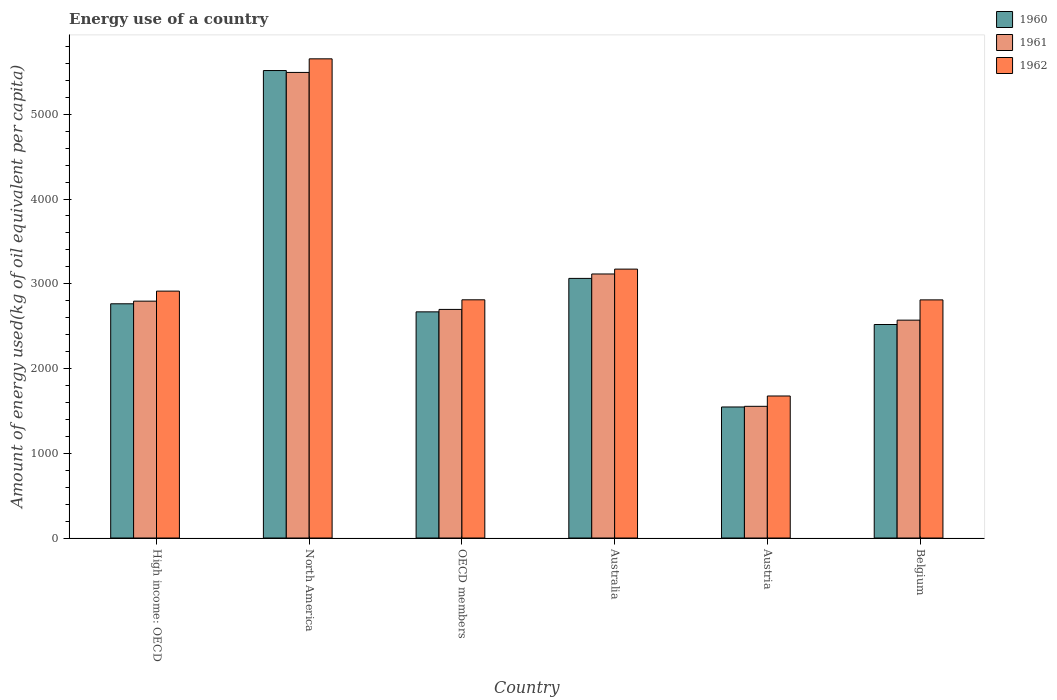How many groups of bars are there?
Make the answer very short. 6. Are the number of bars on each tick of the X-axis equal?
Keep it short and to the point. Yes. How many bars are there on the 1st tick from the right?
Your answer should be compact. 3. In how many cases, is the number of bars for a given country not equal to the number of legend labels?
Keep it short and to the point. 0. What is the amount of energy used in in 1962 in OECD members?
Provide a short and direct response. 2810.85. Across all countries, what is the maximum amount of energy used in in 1960?
Give a very brief answer. 5516.36. Across all countries, what is the minimum amount of energy used in in 1960?
Make the answer very short. 1546.26. What is the total amount of energy used in in 1961 in the graph?
Ensure brevity in your answer.  1.82e+04. What is the difference between the amount of energy used in in 1960 in Austria and that in High income: OECD?
Provide a short and direct response. -1217.7. What is the difference between the amount of energy used in in 1960 in North America and the amount of energy used in in 1961 in Austria?
Make the answer very short. 3962.32. What is the average amount of energy used in in 1960 per country?
Provide a succinct answer. 3013.05. What is the difference between the amount of energy used in of/in 1961 and amount of energy used in of/in 1962 in Belgium?
Keep it short and to the point. -239.25. What is the ratio of the amount of energy used in in 1960 in Australia to that in Austria?
Your answer should be very brief. 1.98. Is the amount of energy used in in 1962 in High income: OECD less than that in OECD members?
Ensure brevity in your answer.  No. What is the difference between the highest and the second highest amount of energy used in in 1962?
Give a very brief answer. -259.55. What is the difference between the highest and the lowest amount of energy used in in 1960?
Your answer should be compact. 3970.09. Is the sum of the amount of energy used in in 1962 in High income: OECD and North America greater than the maximum amount of energy used in in 1960 across all countries?
Offer a very short reply. Yes. What does the 1st bar from the left in North America represents?
Keep it short and to the point. 1960. How many bars are there?
Ensure brevity in your answer.  18. Are all the bars in the graph horizontal?
Provide a succinct answer. No. How many countries are there in the graph?
Provide a short and direct response. 6. What is the difference between two consecutive major ticks on the Y-axis?
Your answer should be compact. 1000. Does the graph contain grids?
Offer a terse response. No. Where does the legend appear in the graph?
Offer a terse response. Top right. How many legend labels are there?
Your response must be concise. 3. What is the title of the graph?
Provide a short and direct response. Energy use of a country. Does "1968" appear as one of the legend labels in the graph?
Your response must be concise. No. What is the label or title of the Y-axis?
Make the answer very short. Amount of energy used(kg of oil equivalent per capita). What is the Amount of energy used(kg of oil equivalent per capita) of 1960 in High income: OECD?
Keep it short and to the point. 2763.96. What is the Amount of energy used(kg of oil equivalent per capita) in 1961 in High income: OECD?
Give a very brief answer. 2795.14. What is the Amount of energy used(kg of oil equivalent per capita) of 1962 in High income: OECD?
Give a very brief answer. 2913.43. What is the Amount of energy used(kg of oil equivalent per capita) in 1960 in North America?
Keep it short and to the point. 5516.36. What is the Amount of energy used(kg of oil equivalent per capita) of 1961 in North America?
Give a very brief answer. 5494.09. What is the Amount of energy used(kg of oil equivalent per capita) of 1962 in North America?
Your response must be concise. 5654.54. What is the Amount of energy used(kg of oil equivalent per capita) of 1960 in OECD members?
Your response must be concise. 2668.69. What is the Amount of energy used(kg of oil equivalent per capita) of 1961 in OECD members?
Provide a succinct answer. 2697.51. What is the Amount of energy used(kg of oil equivalent per capita) in 1962 in OECD members?
Ensure brevity in your answer.  2810.85. What is the Amount of energy used(kg of oil equivalent per capita) of 1960 in Australia?
Your response must be concise. 3063.55. What is the Amount of energy used(kg of oil equivalent per capita) in 1961 in Australia?
Provide a short and direct response. 3115.79. What is the Amount of energy used(kg of oil equivalent per capita) in 1962 in Australia?
Make the answer very short. 3172.97. What is the Amount of energy used(kg of oil equivalent per capita) in 1960 in Austria?
Your answer should be compact. 1546.26. What is the Amount of energy used(kg of oil equivalent per capita) of 1961 in Austria?
Provide a short and direct response. 1554.03. What is the Amount of energy used(kg of oil equivalent per capita) in 1962 in Austria?
Offer a very short reply. 1675.87. What is the Amount of energy used(kg of oil equivalent per capita) in 1960 in Belgium?
Provide a short and direct response. 2519.5. What is the Amount of energy used(kg of oil equivalent per capita) in 1961 in Belgium?
Keep it short and to the point. 2570.82. What is the Amount of energy used(kg of oil equivalent per capita) of 1962 in Belgium?
Provide a succinct answer. 2810.06. Across all countries, what is the maximum Amount of energy used(kg of oil equivalent per capita) in 1960?
Provide a short and direct response. 5516.36. Across all countries, what is the maximum Amount of energy used(kg of oil equivalent per capita) in 1961?
Ensure brevity in your answer.  5494.09. Across all countries, what is the maximum Amount of energy used(kg of oil equivalent per capita) in 1962?
Provide a succinct answer. 5654.54. Across all countries, what is the minimum Amount of energy used(kg of oil equivalent per capita) of 1960?
Offer a terse response. 1546.26. Across all countries, what is the minimum Amount of energy used(kg of oil equivalent per capita) in 1961?
Make the answer very short. 1554.03. Across all countries, what is the minimum Amount of energy used(kg of oil equivalent per capita) of 1962?
Offer a terse response. 1675.87. What is the total Amount of energy used(kg of oil equivalent per capita) in 1960 in the graph?
Your response must be concise. 1.81e+04. What is the total Amount of energy used(kg of oil equivalent per capita) in 1961 in the graph?
Provide a short and direct response. 1.82e+04. What is the total Amount of energy used(kg of oil equivalent per capita) in 1962 in the graph?
Make the answer very short. 1.90e+04. What is the difference between the Amount of energy used(kg of oil equivalent per capita) in 1960 in High income: OECD and that in North America?
Provide a succinct answer. -2752.4. What is the difference between the Amount of energy used(kg of oil equivalent per capita) of 1961 in High income: OECD and that in North America?
Your answer should be very brief. -2698.95. What is the difference between the Amount of energy used(kg of oil equivalent per capita) in 1962 in High income: OECD and that in North America?
Offer a very short reply. -2741.12. What is the difference between the Amount of energy used(kg of oil equivalent per capita) of 1960 in High income: OECD and that in OECD members?
Make the answer very short. 95.27. What is the difference between the Amount of energy used(kg of oil equivalent per capita) in 1961 in High income: OECD and that in OECD members?
Your response must be concise. 97.63. What is the difference between the Amount of energy used(kg of oil equivalent per capita) in 1962 in High income: OECD and that in OECD members?
Your answer should be very brief. 102.57. What is the difference between the Amount of energy used(kg of oil equivalent per capita) in 1960 in High income: OECD and that in Australia?
Your answer should be very brief. -299.59. What is the difference between the Amount of energy used(kg of oil equivalent per capita) of 1961 in High income: OECD and that in Australia?
Provide a short and direct response. -320.65. What is the difference between the Amount of energy used(kg of oil equivalent per capita) in 1962 in High income: OECD and that in Australia?
Keep it short and to the point. -259.55. What is the difference between the Amount of energy used(kg of oil equivalent per capita) in 1960 in High income: OECD and that in Austria?
Your answer should be compact. 1217.7. What is the difference between the Amount of energy used(kg of oil equivalent per capita) of 1961 in High income: OECD and that in Austria?
Your answer should be very brief. 1241.11. What is the difference between the Amount of energy used(kg of oil equivalent per capita) of 1962 in High income: OECD and that in Austria?
Make the answer very short. 1237.55. What is the difference between the Amount of energy used(kg of oil equivalent per capita) in 1960 in High income: OECD and that in Belgium?
Give a very brief answer. 244.46. What is the difference between the Amount of energy used(kg of oil equivalent per capita) in 1961 in High income: OECD and that in Belgium?
Provide a short and direct response. 224.32. What is the difference between the Amount of energy used(kg of oil equivalent per capita) of 1962 in High income: OECD and that in Belgium?
Keep it short and to the point. 103.36. What is the difference between the Amount of energy used(kg of oil equivalent per capita) in 1960 in North America and that in OECD members?
Your response must be concise. 2847.66. What is the difference between the Amount of energy used(kg of oil equivalent per capita) of 1961 in North America and that in OECD members?
Your answer should be compact. 2796.57. What is the difference between the Amount of energy used(kg of oil equivalent per capita) of 1962 in North America and that in OECD members?
Keep it short and to the point. 2843.69. What is the difference between the Amount of energy used(kg of oil equivalent per capita) of 1960 in North America and that in Australia?
Give a very brief answer. 2452.8. What is the difference between the Amount of energy used(kg of oil equivalent per capita) in 1961 in North America and that in Australia?
Offer a very short reply. 2378.3. What is the difference between the Amount of energy used(kg of oil equivalent per capita) of 1962 in North America and that in Australia?
Your answer should be very brief. 2481.57. What is the difference between the Amount of energy used(kg of oil equivalent per capita) in 1960 in North America and that in Austria?
Make the answer very short. 3970.09. What is the difference between the Amount of energy used(kg of oil equivalent per capita) in 1961 in North America and that in Austria?
Provide a succinct answer. 3940.05. What is the difference between the Amount of energy used(kg of oil equivalent per capita) of 1962 in North America and that in Austria?
Offer a terse response. 3978.67. What is the difference between the Amount of energy used(kg of oil equivalent per capita) of 1960 in North America and that in Belgium?
Keep it short and to the point. 2996.86. What is the difference between the Amount of energy used(kg of oil equivalent per capita) of 1961 in North America and that in Belgium?
Keep it short and to the point. 2923.27. What is the difference between the Amount of energy used(kg of oil equivalent per capita) of 1962 in North America and that in Belgium?
Give a very brief answer. 2844.48. What is the difference between the Amount of energy used(kg of oil equivalent per capita) in 1960 in OECD members and that in Australia?
Provide a succinct answer. -394.86. What is the difference between the Amount of energy used(kg of oil equivalent per capita) in 1961 in OECD members and that in Australia?
Offer a terse response. -418.27. What is the difference between the Amount of energy used(kg of oil equivalent per capita) of 1962 in OECD members and that in Australia?
Your response must be concise. -362.12. What is the difference between the Amount of energy used(kg of oil equivalent per capita) of 1960 in OECD members and that in Austria?
Provide a short and direct response. 1122.43. What is the difference between the Amount of energy used(kg of oil equivalent per capita) of 1961 in OECD members and that in Austria?
Offer a terse response. 1143.48. What is the difference between the Amount of energy used(kg of oil equivalent per capita) of 1962 in OECD members and that in Austria?
Provide a succinct answer. 1134.98. What is the difference between the Amount of energy used(kg of oil equivalent per capita) in 1960 in OECD members and that in Belgium?
Make the answer very short. 149.2. What is the difference between the Amount of energy used(kg of oil equivalent per capita) in 1961 in OECD members and that in Belgium?
Offer a terse response. 126.7. What is the difference between the Amount of energy used(kg of oil equivalent per capita) of 1962 in OECD members and that in Belgium?
Your response must be concise. 0.79. What is the difference between the Amount of energy used(kg of oil equivalent per capita) in 1960 in Australia and that in Austria?
Ensure brevity in your answer.  1517.29. What is the difference between the Amount of energy used(kg of oil equivalent per capita) in 1961 in Australia and that in Austria?
Provide a short and direct response. 1561.75. What is the difference between the Amount of energy used(kg of oil equivalent per capita) in 1962 in Australia and that in Austria?
Ensure brevity in your answer.  1497.1. What is the difference between the Amount of energy used(kg of oil equivalent per capita) of 1960 in Australia and that in Belgium?
Your answer should be compact. 544.06. What is the difference between the Amount of energy used(kg of oil equivalent per capita) of 1961 in Australia and that in Belgium?
Give a very brief answer. 544.97. What is the difference between the Amount of energy used(kg of oil equivalent per capita) in 1962 in Australia and that in Belgium?
Give a very brief answer. 362.91. What is the difference between the Amount of energy used(kg of oil equivalent per capita) in 1960 in Austria and that in Belgium?
Give a very brief answer. -973.24. What is the difference between the Amount of energy used(kg of oil equivalent per capita) of 1961 in Austria and that in Belgium?
Ensure brevity in your answer.  -1016.78. What is the difference between the Amount of energy used(kg of oil equivalent per capita) in 1962 in Austria and that in Belgium?
Your response must be concise. -1134.19. What is the difference between the Amount of energy used(kg of oil equivalent per capita) of 1960 in High income: OECD and the Amount of energy used(kg of oil equivalent per capita) of 1961 in North America?
Give a very brief answer. -2730.13. What is the difference between the Amount of energy used(kg of oil equivalent per capita) in 1960 in High income: OECD and the Amount of energy used(kg of oil equivalent per capita) in 1962 in North America?
Offer a terse response. -2890.59. What is the difference between the Amount of energy used(kg of oil equivalent per capita) in 1961 in High income: OECD and the Amount of energy used(kg of oil equivalent per capita) in 1962 in North America?
Offer a terse response. -2859.4. What is the difference between the Amount of energy used(kg of oil equivalent per capita) of 1960 in High income: OECD and the Amount of energy used(kg of oil equivalent per capita) of 1961 in OECD members?
Offer a very short reply. 66.45. What is the difference between the Amount of energy used(kg of oil equivalent per capita) of 1960 in High income: OECD and the Amount of energy used(kg of oil equivalent per capita) of 1962 in OECD members?
Ensure brevity in your answer.  -46.89. What is the difference between the Amount of energy used(kg of oil equivalent per capita) of 1961 in High income: OECD and the Amount of energy used(kg of oil equivalent per capita) of 1962 in OECD members?
Offer a very short reply. -15.71. What is the difference between the Amount of energy used(kg of oil equivalent per capita) in 1960 in High income: OECD and the Amount of energy used(kg of oil equivalent per capita) in 1961 in Australia?
Keep it short and to the point. -351.83. What is the difference between the Amount of energy used(kg of oil equivalent per capita) of 1960 in High income: OECD and the Amount of energy used(kg of oil equivalent per capita) of 1962 in Australia?
Ensure brevity in your answer.  -409.02. What is the difference between the Amount of energy used(kg of oil equivalent per capita) of 1961 in High income: OECD and the Amount of energy used(kg of oil equivalent per capita) of 1962 in Australia?
Your answer should be compact. -377.83. What is the difference between the Amount of energy used(kg of oil equivalent per capita) in 1960 in High income: OECD and the Amount of energy used(kg of oil equivalent per capita) in 1961 in Austria?
Offer a very short reply. 1209.92. What is the difference between the Amount of energy used(kg of oil equivalent per capita) in 1960 in High income: OECD and the Amount of energy used(kg of oil equivalent per capita) in 1962 in Austria?
Your answer should be compact. 1088.09. What is the difference between the Amount of energy used(kg of oil equivalent per capita) of 1961 in High income: OECD and the Amount of energy used(kg of oil equivalent per capita) of 1962 in Austria?
Provide a short and direct response. 1119.27. What is the difference between the Amount of energy used(kg of oil equivalent per capita) in 1960 in High income: OECD and the Amount of energy used(kg of oil equivalent per capita) in 1961 in Belgium?
Make the answer very short. 193.14. What is the difference between the Amount of energy used(kg of oil equivalent per capita) in 1960 in High income: OECD and the Amount of energy used(kg of oil equivalent per capita) in 1962 in Belgium?
Provide a succinct answer. -46.1. What is the difference between the Amount of energy used(kg of oil equivalent per capita) in 1961 in High income: OECD and the Amount of energy used(kg of oil equivalent per capita) in 1962 in Belgium?
Your answer should be very brief. -14.92. What is the difference between the Amount of energy used(kg of oil equivalent per capita) in 1960 in North America and the Amount of energy used(kg of oil equivalent per capita) in 1961 in OECD members?
Keep it short and to the point. 2818.84. What is the difference between the Amount of energy used(kg of oil equivalent per capita) in 1960 in North America and the Amount of energy used(kg of oil equivalent per capita) in 1962 in OECD members?
Offer a terse response. 2705.5. What is the difference between the Amount of energy used(kg of oil equivalent per capita) of 1961 in North America and the Amount of energy used(kg of oil equivalent per capita) of 1962 in OECD members?
Your answer should be compact. 2683.23. What is the difference between the Amount of energy used(kg of oil equivalent per capita) of 1960 in North America and the Amount of energy used(kg of oil equivalent per capita) of 1961 in Australia?
Give a very brief answer. 2400.57. What is the difference between the Amount of energy used(kg of oil equivalent per capita) in 1960 in North America and the Amount of energy used(kg of oil equivalent per capita) in 1962 in Australia?
Make the answer very short. 2343.38. What is the difference between the Amount of energy used(kg of oil equivalent per capita) in 1961 in North America and the Amount of energy used(kg of oil equivalent per capita) in 1962 in Australia?
Your answer should be very brief. 2321.11. What is the difference between the Amount of energy used(kg of oil equivalent per capita) of 1960 in North America and the Amount of energy used(kg of oil equivalent per capita) of 1961 in Austria?
Your answer should be compact. 3962.32. What is the difference between the Amount of energy used(kg of oil equivalent per capita) in 1960 in North America and the Amount of energy used(kg of oil equivalent per capita) in 1962 in Austria?
Offer a terse response. 3840.48. What is the difference between the Amount of energy used(kg of oil equivalent per capita) in 1961 in North America and the Amount of energy used(kg of oil equivalent per capita) in 1962 in Austria?
Your answer should be very brief. 3818.21. What is the difference between the Amount of energy used(kg of oil equivalent per capita) in 1960 in North America and the Amount of energy used(kg of oil equivalent per capita) in 1961 in Belgium?
Provide a succinct answer. 2945.54. What is the difference between the Amount of energy used(kg of oil equivalent per capita) of 1960 in North America and the Amount of energy used(kg of oil equivalent per capita) of 1962 in Belgium?
Ensure brevity in your answer.  2706.29. What is the difference between the Amount of energy used(kg of oil equivalent per capita) of 1961 in North America and the Amount of energy used(kg of oil equivalent per capita) of 1962 in Belgium?
Provide a short and direct response. 2684.03. What is the difference between the Amount of energy used(kg of oil equivalent per capita) in 1960 in OECD members and the Amount of energy used(kg of oil equivalent per capita) in 1961 in Australia?
Offer a terse response. -447.09. What is the difference between the Amount of energy used(kg of oil equivalent per capita) of 1960 in OECD members and the Amount of energy used(kg of oil equivalent per capita) of 1962 in Australia?
Provide a short and direct response. -504.28. What is the difference between the Amount of energy used(kg of oil equivalent per capita) in 1961 in OECD members and the Amount of energy used(kg of oil equivalent per capita) in 1962 in Australia?
Your answer should be compact. -475.46. What is the difference between the Amount of energy used(kg of oil equivalent per capita) of 1960 in OECD members and the Amount of energy used(kg of oil equivalent per capita) of 1961 in Austria?
Offer a terse response. 1114.66. What is the difference between the Amount of energy used(kg of oil equivalent per capita) in 1960 in OECD members and the Amount of energy used(kg of oil equivalent per capita) in 1962 in Austria?
Provide a succinct answer. 992.82. What is the difference between the Amount of energy used(kg of oil equivalent per capita) of 1961 in OECD members and the Amount of energy used(kg of oil equivalent per capita) of 1962 in Austria?
Keep it short and to the point. 1021.64. What is the difference between the Amount of energy used(kg of oil equivalent per capita) of 1960 in OECD members and the Amount of energy used(kg of oil equivalent per capita) of 1961 in Belgium?
Offer a terse response. 97.88. What is the difference between the Amount of energy used(kg of oil equivalent per capita) in 1960 in OECD members and the Amount of energy used(kg of oil equivalent per capita) in 1962 in Belgium?
Your answer should be very brief. -141.37. What is the difference between the Amount of energy used(kg of oil equivalent per capita) of 1961 in OECD members and the Amount of energy used(kg of oil equivalent per capita) of 1962 in Belgium?
Make the answer very short. -112.55. What is the difference between the Amount of energy used(kg of oil equivalent per capita) in 1960 in Australia and the Amount of energy used(kg of oil equivalent per capita) in 1961 in Austria?
Your answer should be very brief. 1509.52. What is the difference between the Amount of energy used(kg of oil equivalent per capita) of 1960 in Australia and the Amount of energy used(kg of oil equivalent per capita) of 1962 in Austria?
Ensure brevity in your answer.  1387.68. What is the difference between the Amount of energy used(kg of oil equivalent per capita) of 1961 in Australia and the Amount of energy used(kg of oil equivalent per capita) of 1962 in Austria?
Provide a short and direct response. 1439.91. What is the difference between the Amount of energy used(kg of oil equivalent per capita) of 1960 in Australia and the Amount of energy used(kg of oil equivalent per capita) of 1961 in Belgium?
Make the answer very short. 492.74. What is the difference between the Amount of energy used(kg of oil equivalent per capita) in 1960 in Australia and the Amount of energy used(kg of oil equivalent per capita) in 1962 in Belgium?
Give a very brief answer. 253.49. What is the difference between the Amount of energy used(kg of oil equivalent per capita) of 1961 in Australia and the Amount of energy used(kg of oil equivalent per capita) of 1962 in Belgium?
Make the answer very short. 305.73. What is the difference between the Amount of energy used(kg of oil equivalent per capita) of 1960 in Austria and the Amount of energy used(kg of oil equivalent per capita) of 1961 in Belgium?
Make the answer very short. -1024.55. What is the difference between the Amount of energy used(kg of oil equivalent per capita) of 1960 in Austria and the Amount of energy used(kg of oil equivalent per capita) of 1962 in Belgium?
Give a very brief answer. -1263.8. What is the difference between the Amount of energy used(kg of oil equivalent per capita) in 1961 in Austria and the Amount of energy used(kg of oil equivalent per capita) in 1962 in Belgium?
Provide a succinct answer. -1256.03. What is the average Amount of energy used(kg of oil equivalent per capita) in 1960 per country?
Provide a short and direct response. 3013.05. What is the average Amount of energy used(kg of oil equivalent per capita) of 1961 per country?
Your answer should be compact. 3037.9. What is the average Amount of energy used(kg of oil equivalent per capita) in 1962 per country?
Provide a short and direct response. 3172.96. What is the difference between the Amount of energy used(kg of oil equivalent per capita) of 1960 and Amount of energy used(kg of oil equivalent per capita) of 1961 in High income: OECD?
Make the answer very short. -31.18. What is the difference between the Amount of energy used(kg of oil equivalent per capita) in 1960 and Amount of energy used(kg of oil equivalent per capita) in 1962 in High income: OECD?
Provide a short and direct response. -149.47. What is the difference between the Amount of energy used(kg of oil equivalent per capita) of 1961 and Amount of energy used(kg of oil equivalent per capita) of 1962 in High income: OECD?
Your answer should be compact. -118.28. What is the difference between the Amount of energy used(kg of oil equivalent per capita) of 1960 and Amount of energy used(kg of oil equivalent per capita) of 1961 in North America?
Your answer should be very brief. 22.27. What is the difference between the Amount of energy used(kg of oil equivalent per capita) in 1960 and Amount of energy used(kg of oil equivalent per capita) in 1962 in North America?
Make the answer very short. -138.19. What is the difference between the Amount of energy used(kg of oil equivalent per capita) of 1961 and Amount of energy used(kg of oil equivalent per capita) of 1962 in North America?
Ensure brevity in your answer.  -160.46. What is the difference between the Amount of energy used(kg of oil equivalent per capita) in 1960 and Amount of energy used(kg of oil equivalent per capita) in 1961 in OECD members?
Offer a terse response. -28.82. What is the difference between the Amount of energy used(kg of oil equivalent per capita) of 1960 and Amount of energy used(kg of oil equivalent per capita) of 1962 in OECD members?
Your answer should be compact. -142.16. What is the difference between the Amount of energy used(kg of oil equivalent per capita) of 1961 and Amount of energy used(kg of oil equivalent per capita) of 1962 in OECD members?
Provide a short and direct response. -113.34. What is the difference between the Amount of energy used(kg of oil equivalent per capita) of 1960 and Amount of energy used(kg of oil equivalent per capita) of 1961 in Australia?
Ensure brevity in your answer.  -52.23. What is the difference between the Amount of energy used(kg of oil equivalent per capita) in 1960 and Amount of energy used(kg of oil equivalent per capita) in 1962 in Australia?
Offer a terse response. -109.42. What is the difference between the Amount of energy used(kg of oil equivalent per capita) in 1961 and Amount of energy used(kg of oil equivalent per capita) in 1962 in Australia?
Make the answer very short. -57.19. What is the difference between the Amount of energy used(kg of oil equivalent per capita) in 1960 and Amount of energy used(kg of oil equivalent per capita) in 1961 in Austria?
Ensure brevity in your answer.  -7.77. What is the difference between the Amount of energy used(kg of oil equivalent per capita) in 1960 and Amount of energy used(kg of oil equivalent per capita) in 1962 in Austria?
Offer a terse response. -129.61. What is the difference between the Amount of energy used(kg of oil equivalent per capita) of 1961 and Amount of energy used(kg of oil equivalent per capita) of 1962 in Austria?
Provide a short and direct response. -121.84. What is the difference between the Amount of energy used(kg of oil equivalent per capita) of 1960 and Amount of energy used(kg of oil equivalent per capita) of 1961 in Belgium?
Provide a short and direct response. -51.32. What is the difference between the Amount of energy used(kg of oil equivalent per capita) in 1960 and Amount of energy used(kg of oil equivalent per capita) in 1962 in Belgium?
Keep it short and to the point. -290.56. What is the difference between the Amount of energy used(kg of oil equivalent per capita) in 1961 and Amount of energy used(kg of oil equivalent per capita) in 1962 in Belgium?
Offer a terse response. -239.25. What is the ratio of the Amount of energy used(kg of oil equivalent per capita) of 1960 in High income: OECD to that in North America?
Your answer should be compact. 0.5. What is the ratio of the Amount of energy used(kg of oil equivalent per capita) in 1961 in High income: OECD to that in North America?
Provide a succinct answer. 0.51. What is the ratio of the Amount of energy used(kg of oil equivalent per capita) of 1962 in High income: OECD to that in North America?
Offer a terse response. 0.52. What is the ratio of the Amount of energy used(kg of oil equivalent per capita) in 1960 in High income: OECD to that in OECD members?
Make the answer very short. 1.04. What is the ratio of the Amount of energy used(kg of oil equivalent per capita) of 1961 in High income: OECD to that in OECD members?
Offer a terse response. 1.04. What is the ratio of the Amount of energy used(kg of oil equivalent per capita) of 1962 in High income: OECD to that in OECD members?
Your response must be concise. 1.04. What is the ratio of the Amount of energy used(kg of oil equivalent per capita) of 1960 in High income: OECD to that in Australia?
Offer a very short reply. 0.9. What is the ratio of the Amount of energy used(kg of oil equivalent per capita) of 1961 in High income: OECD to that in Australia?
Offer a very short reply. 0.9. What is the ratio of the Amount of energy used(kg of oil equivalent per capita) in 1962 in High income: OECD to that in Australia?
Give a very brief answer. 0.92. What is the ratio of the Amount of energy used(kg of oil equivalent per capita) in 1960 in High income: OECD to that in Austria?
Offer a very short reply. 1.79. What is the ratio of the Amount of energy used(kg of oil equivalent per capita) in 1961 in High income: OECD to that in Austria?
Provide a succinct answer. 1.8. What is the ratio of the Amount of energy used(kg of oil equivalent per capita) in 1962 in High income: OECD to that in Austria?
Your response must be concise. 1.74. What is the ratio of the Amount of energy used(kg of oil equivalent per capita) in 1960 in High income: OECD to that in Belgium?
Provide a succinct answer. 1.1. What is the ratio of the Amount of energy used(kg of oil equivalent per capita) of 1961 in High income: OECD to that in Belgium?
Offer a terse response. 1.09. What is the ratio of the Amount of energy used(kg of oil equivalent per capita) in 1962 in High income: OECD to that in Belgium?
Keep it short and to the point. 1.04. What is the ratio of the Amount of energy used(kg of oil equivalent per capita) in 1960 in North America to that in OECD members?
Your answer should be very brief. 2.07. What is the ratio of the Amount of energy used(kg of oil equivalent per capita) in 1961 in North America to that in OECD members?
Make the answer very short. 2.04. What is the ratio of the Amount of energy used(kg of oil equivalent per capita) of 1962 in North America to that in OECD members?
Your answer should be compact. 2.01. What is the ratio of the Amount of energy used(kg of oil equivalent per capita) in 1960 in North America to that in Australia?
Ensure brevity in your answer.  1.8. What is the ratio of the Amount of energy used(kg of oil equivalent per capita) in 1961 in North America to that in Australia?
Your answer should be very brief. 1.76. What is the ratio of the Amount of energy used(kg of oil equivalent per capita) in 1962 in North America to that in Australia?
Keep it short and to the point. 1.78. What is the ratio of the Amount of energy used(kg of oil equivalent per capita) in 1960 in North America to that in Austria?
Offer a very short reply. 3.57. What is the ratio of the Amount of energy used(kg of oil equivalent per capita) in 1961 in North America to that in Austria?
Provide a short and direct response. 3.54. What is the ratio of the Amount of energy used(kg of oil equivalent per capita) in 1962 in North America to that in Austria?
Give a very brief answer. 3.37. What is the ratio of the Amount of energy used(kg of oil equivalent per capita) of 1960 in North America to that in Belgium?
Offer a terse response. 2.19. What is the ratio of the Amount of energy used(kg of oil equivalent per capita) in 1961 in North America to that in Belgium?
Make the answer very short. 2.14. What is the ratio of the Amount of energy used(kg of oil equivalent per capita) in 1962 in North America to that in Belgium?
Give a very brief answer. 2.01. What is the ratio of the Amount of energy used(kg of oil equivalent per capita) in 1960 in OECD members to that in Australia?
Make the answer very short. 0.87. What is the ratio of the Amount of energy used(kg of oil equivalent per capita) of 1961 in OECD members to that in Australia?
Keep it short and to the point. 0.87. What is the ratio of the Amount of energy used(kg of oil equivalent per capita) in 1962 in OECD members to that in Australia?
Give a very brief answer. 0.89. What is the ratio of the Amount of energy used(kg of oil equivalent per capita) of 1960 in OECD members to that in Austria?
Offer a terse response. 1.73. What is the ratio of the Amount of energy used(kg of oil equivalent per capita) of 1961 in OECD members to that in Austria?
Make the answer very short. 1.74. What is the ratio of the Amount of energy used(kg of oil equivalent per capita) in 1962 in OECD members to that in Austria?
Make the answer very short. 1.68. What is the ratio of the Amount of energy used(kg of oil equivalent per capita) in 1960 in OECD members to that in Belgium?
Your answer should be compact. 1.06. What is the ratio of the Amount of energy used(kg of oil equivalent per capita) in 1961 in OECD members to that in Belgium?
Your response must be concise. 1.05. What is the ratio of the Amount of energy used(kg of oil equivalent per capita) in 1962 in OECD members to that in Belgium?
Your answer should be very brief. 1. What is the ratio of the Amount of energy used(kg of oil equivalent per capita) in 1960 in Australia to that in Austria?
Provide a succinct answer. 1.98. What is the ratio of the Amount of energy used(kg of oil equivalent per capita) in 1961 in Australia to that in Austria?
Offer a terse response. 2. What is the ratio of the Amount of energy used(kg of oil equivalent per capita) in 1962 in Australia to that in Austria?
Ensure brevity in your answer.  1.89. What is the ratio of the Amount of energy used(kg of oil equivalent per capita) in 1960 in Australia to that in Belgium?
Offer a very short reply. 1.22. What is the ratio of the Amount of energy used(kg of oil equivalent per capita) of 1961 in Australia to that in Belgium?
Your answer should be very brief. 1.21. What is the ratio of the Amount of energy used(kg of oil equivalent per capita) in 1962 in Australia to that in Belgium?
Make the answer very short. 1.13. What is the ratio of the Amount of energy used(kg of oil equivalent per capita) of 1960 in Austria to that in Belgium?
Provide a succinct answer. 0.61. What is the ratio of the Amount of energy used(kg of oil equivalent per capita) in 1961 in Austria to that in Belgium?
Offer a terse response. 0.6. What is the ratio of the Amount of energy used(kg of oil equivalent per capita) in 1962 in Austria to that in Belgium?
Keep it short and to the point. 0.6. What is the difference between the highest and the second highest Amount of energy used(kg of oil equivalent per capita) of 1960?
Keep it short and to the point. 2452.8. What is the difference between the highest and the second highest Amount of energy used(kg of oil equivalent per capita) in 1961?
Give a very brief answer. 2378.3. What is the difference between the highest and the second highest Amount of energy used(kg of oil equivalent per capita) of 1962?
Offer a terse response. 2481.57. What is the difference between the highest and the lowest Amount of energy used(kg of oil equivalent per capita) in 1960?
Your answer should be very brief. 3970.09. What is the difference between the highest and the lowest Amount of energy used(kg of oil equivalent per capita) of 1961?
Offer a very short reply. 3940.05. What is the difference between the highest and the lowest Amount of energy used(kg of oil equivalent per capita) of 1962?
Ensure brevity in your answer.  3978.67. 